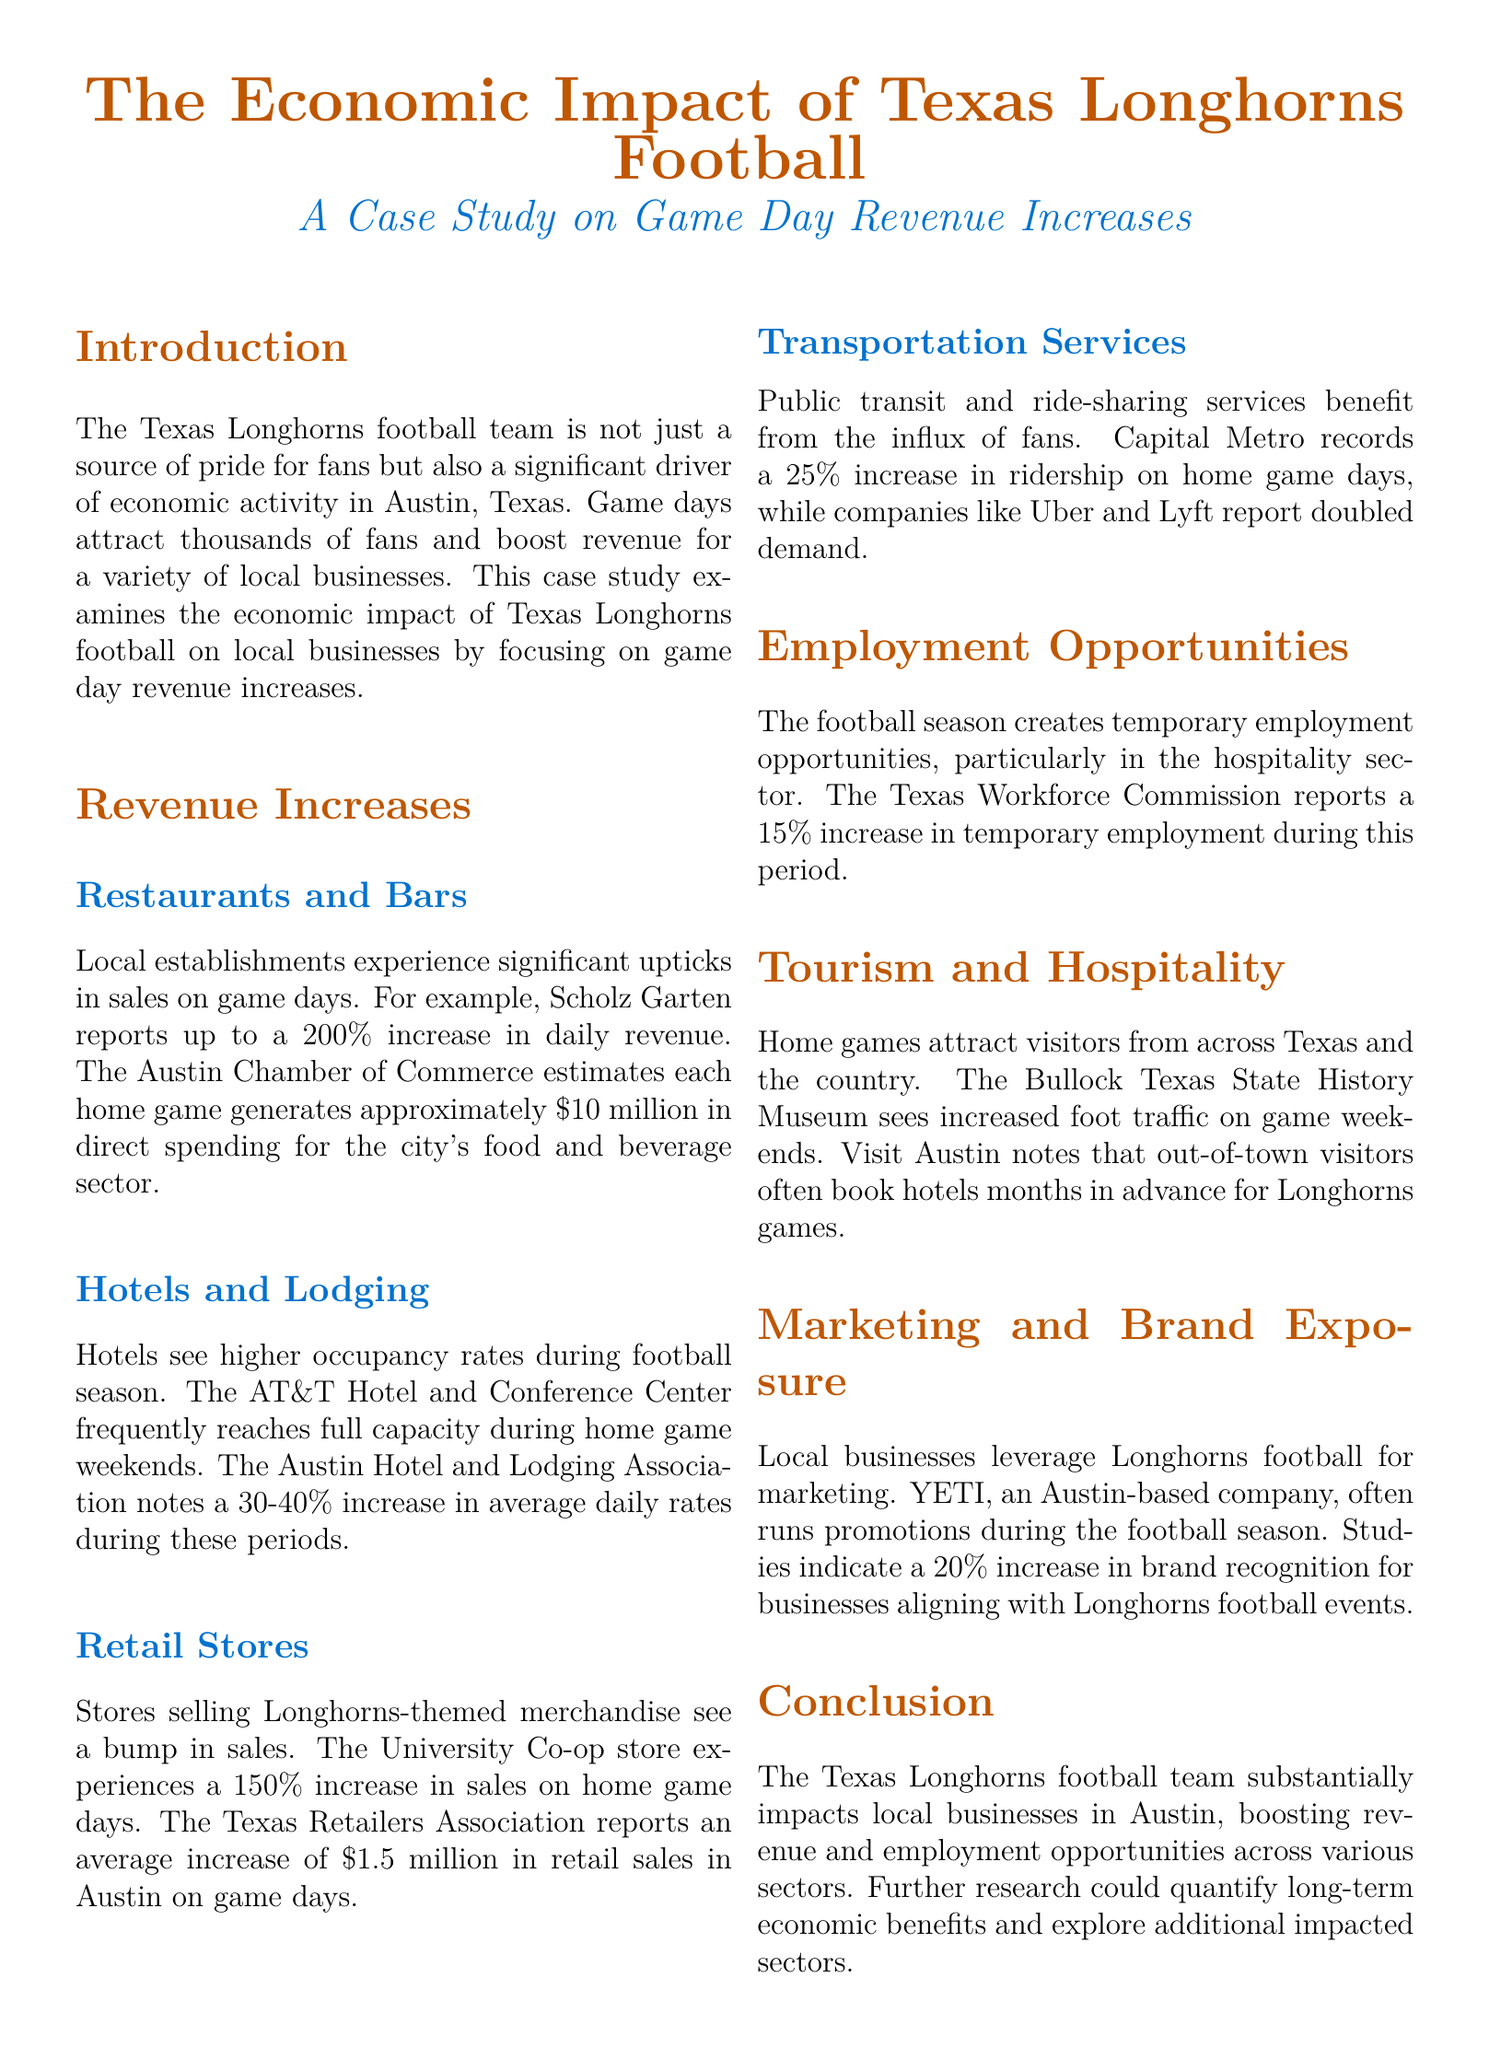What is the estimated direct spending for the city's food and beverage sector during each home game? The document states that each home game generates approximately $10 million in direct spending for the city's food and beverage sector.
Answer: $10 million What is the increase in average daily rates for hotels during home game weekends? According to the Austin Hotel and Lodging Association, there is a 30-40% increase in average daily rates during these periods.
Answer: 30-40% What percentage increase in sales does the University Co-op store experience on home game days? The document indicates that the University Co-op store experiences a 150% increase in sales on home game days.
Answer: 150% By what percentage does Capital Metro record an increase in ridership on home game days? Capital Metro records a 25% increase in ridership on home game days.
Answer: 25% What percentage increase in temporary employment does the Texas Workforce Commission report during the football season? The Texas Workforce Commission reports a 15% increase in temporary employment during this period.
Answer: 15% Why do out-of-town visitors book hotels months in advance? The document notes that out-of-town visitors book hotels months in advance for Longhorns games due to increased tourism and attraction.
Answer: Longhorns games What promotional strategy do local businesses like YETI use during the football season? Local businesses leverage Longhorns football for marketing promotions during the season to attract more customers.
Answer: Marketing promotions How much revenue increase do restaurants like Scholz Garten experience on game days? Scholz Garten reports up to a 200% increase in daily revenue on game days.
Answer: 200% What does the document suggest for further research on the economic benefits of Longhorns football? The conclusion mentions that further research could quantify long-term economic benefits and explore additional impacted sectors.
Answer: Long-term economic benefits 